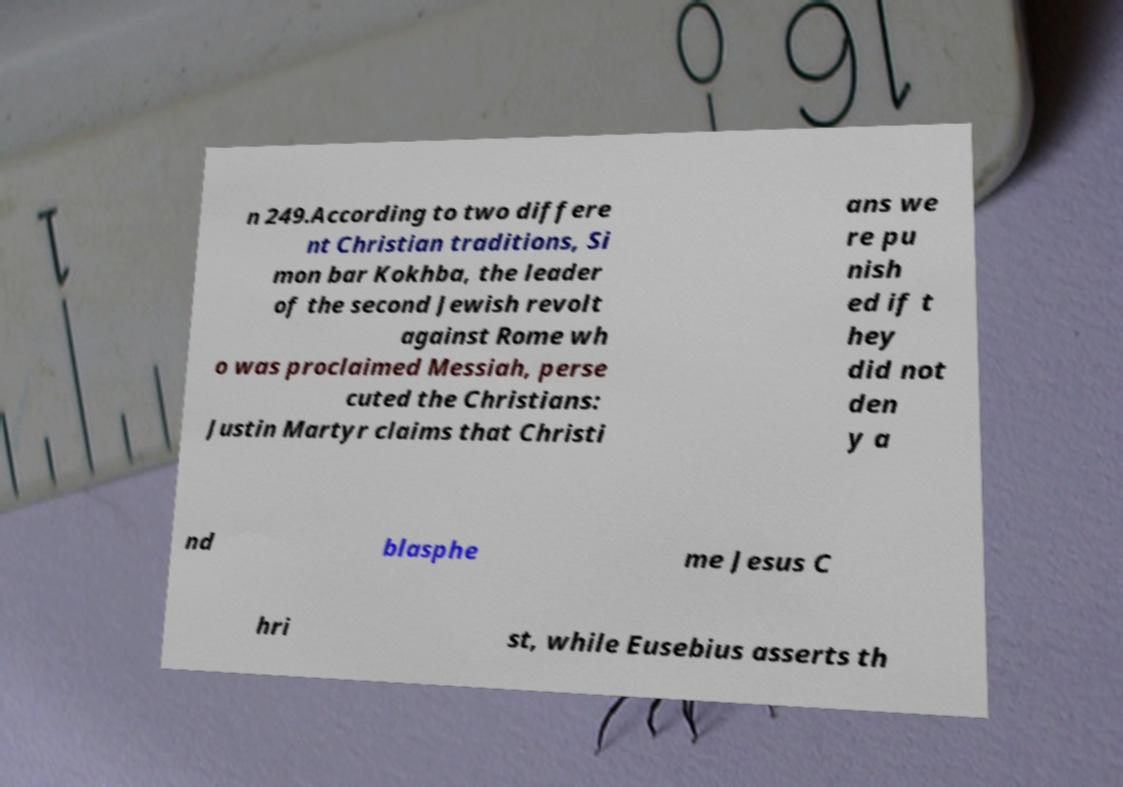Can you accurately transcribe the text from the provided image for me? n 249.According to two differe nt Christian traditions, Si mon bar Kokhba, the leader of the second Jewish revolt against Rome wh o was proclaimed Messiah, perse cuted the Christians: Justin Martyr claims that Christi ans we re pu nish ed if t hey did not den y a nd blasphe me Jesus C hri st, while Eusebius asserts th 